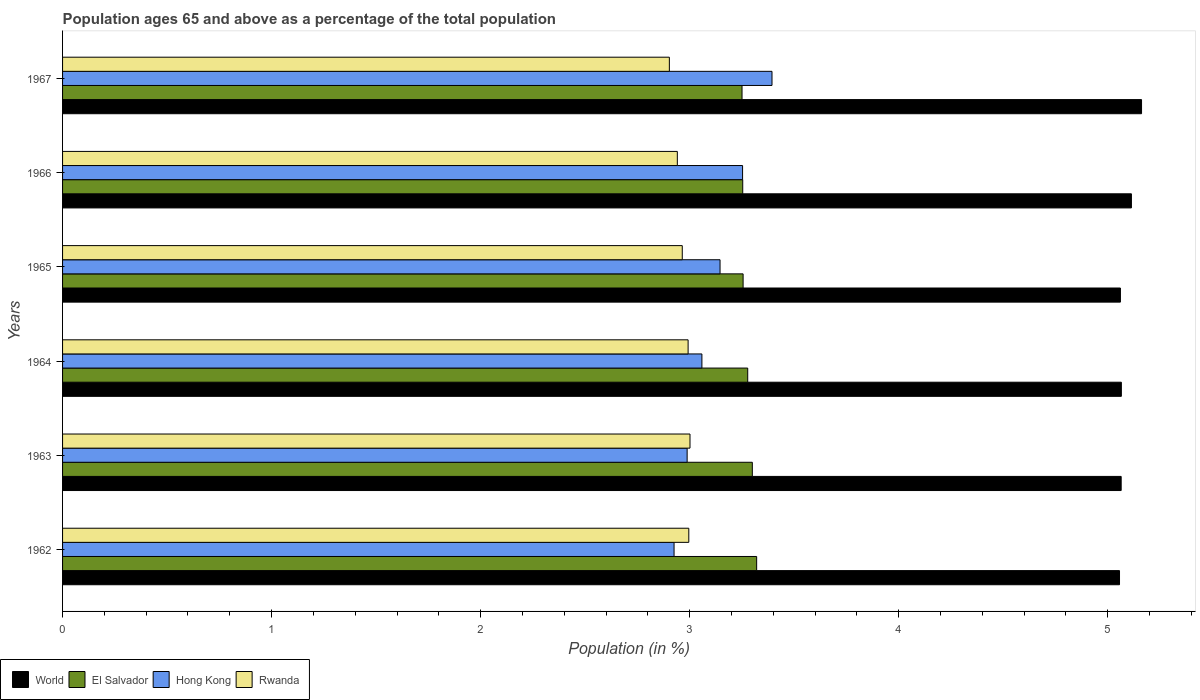How many different coloured bars are there?
Offer a very short reply. 4. Are the number of bars on each tick of the Y-axis equal?
Your answer should be very brief. Yes. How many bars are there on the 1st tick from the top?
Provide a short and direct response. 4. How many bars are there on the 4th tick from the bottom?
Ensure brevity in your answer.  4. In how many cases, is the number of bars for a given year not equal to the number of legend labels?
Ensure brevity in your answer.  0. What is the percentage of the population ages 65 and above in World in 1967?
Keep it short and to the point. 5.16. Across all years, what is the maximum percentage of the population ages 65 and above in Hong Kong?
Provide a short and direct response. 3.39. Across all years, what is the minimum percentage of the population ages 65 and above in Rwanda?
Your response must be concise. 2.9. In which year was the percentage of the population ages 65 and above in El Salvador maximum?
Your answer should be compact. 1962. In which year was the percentage of the population ages 65 and above in Rwanda minimum?
Offer a very short reply. 1967. What is the total percentage of the population ages 65 and above in Hong Kong in the graph?
Provide a short and direct response. 18.76. What is the difference between the percentage of the population ages 65 and above in El Salvador in 1963 and that in 1964?
Offer a very short reply. 0.02. What is the difference between the percentage of the population ages 65 and above in Rwanda in 1964 and the percentage of the population ages 65 and above in World in 1963?
Provide a short and direct response. -2.07. What is the average percentage of the population ages 65 and above in World per year?
Your response must be concise. 5.09. In the year 1963, what is the difference between the percentage of the population ages 65 and above in World and percentage of the population ages 65 and above in Hong Kong?
Keep it short and to the point. 2.08. What is the ratio of the percentage of the population ages 65 and above in World in 1966 to that in 1967?
Offer a terse response. 0.99. What is the difference between the highest and the second highest percentage of the population ages 65 and above in El Salvador?
Offer a very short reply. 0.02. What is the difference between the highest and the lowest percentage of the population ages 65 and above in Hong Kong?
Provide a succinct answer. 0.47. Is it the case that in every year, the sum of the percentage of the population ages 65 and above in Rwanda and percentage of the population ages 65 and above in World is greater than the sum of percentage of the population ages 65 and above in El Salvador and percentage of the population ages 65 and above in Hong Kong?
Offer a very short reply. Yes. What does the 2nd bar from the top in 1962 represents?
Your answer should be very brief. Hong Kong. Is it the case that in every year, the sum of the percentage of the population ages 65 and above in Rwanda and percentage of the population ages 65 and above in Hong Kong is greater than the percentage of the population ages 65 and above in World?
Your response must be concise. Yes. Are all the bars in the graph horizontal?
Your answer should be compact. Yes. How many years are there in the graph?
Your answer should be compact. 6. What is the difference between two consecutive major ticks on the X-axis?
Provide a succinct answer. 1. Does the graph contain grids?
Provide a succinct answer. No. How many legend labels are there?
Keep it short and to the point. 4. What is the title of the graph?
Give a very brief answer. Population ages 65 and above as a percentage of the total population. What is the Population (in %) of World in 1962?
Keep it short and to the point. 5.06. What is the Population (in %) of El Salvador in 1962?
Your answer should be very brief. 3.32. What is the Population (in %) in Hong Kong in 1962?
Provide a succinct answer. 2.93. What is the Population (in %) of Rwanda in 1962?
Your answer should be very brief. 3. What is the Population (in %) in World in 1963?
Offer a very short reply. 5.06. What is the Population (in %) in El Salvador in 1963?
Your answer should be compact. 3.3. What is the Population (in %) in Hong Kong in 1963?
Ensure brevity in your answer.  2.99. What is the Population (in %) of Rwanda in 1963?
Give a very brief answer. 3. What is the Population (in %) of World in 1964?
Give a very brief answer. 5.07. What is the Population (in %) of El Salvador in 1964?
Your answer should be compact. 3.28. What is the Population (in %) in Hong Kong in 1964?
Make the answer very short. 3.06. What is the Population (in %) in Rwanda in 1964?
Your response must be concise. 2.99. What is the Population (in %) in World in 1965?
Ensure brevity in your answer.  5.06. What is the Population (in %) in El Salvador in 1965?
Give a very brief answer. 3.26. What is the Population (in %) in Hong Kong in 1965?
Ensure brevity in your answer.  3.15. What is the Population (in %) in Rwanda in 1965?
Your answer should be very brief. 2.96. What is the Population (in %) of World in 1966?
Your answer should be compact. 5.11. What is the Population (in %) of El Salvador in 1966?
Make the answer very short. 3.25. What is the Population (in %) of Hong Kong in 1966?
Your response must be concise. 3.25. What is the Population (in %) of Rwanda in 1966?
Provide a short and direct response. 2.94. What is the Population (in %) in World in 1967?
Provide a succinct answer. 5.16. What is the Population (in %) in El Salvador in 1967?
Provide a succinct answer. 3.25. What is the Population (in %) in Hong Kong in 1967?
Your answer should be very brief. 3.39. What is the Population (in %) of Rwanda in 1967?
Provide a succinct answer. 2.9. Across all years, what is the maximum Population (in %) of World?
Your response must be concise. 5.16. Across all years, what is the maximum Population (in %) of El Salvador?
Keep it short and to the point. 3.32. Across all years, what is the maximum Population (in %) in Hong Kong?
Your answer should be compact. 3.39. Across all years, what is the maximum Population (in %) in Rwanda?
Provide a succinct answer. 3. Across all years, what is the minimum Population (in %) of World?
Ensure brevity in your answer.  5.06. Across all years, what is the minimum Population (in %) in El Salvador?
Your answer should be compact. 3.25. Across all years, what is the minimum Population (in %) of Hong Kong?
Make the answer very short. 2.93. Across all years, what is the minimum Population (in %) in Rwanda?
Your answer should be compact. 2.9. What is the total Population (in %) of World in the graph?
Provide a succinct answer. 30.52. What is the total Population (in %) in El Salvador in the graph?
Provide a succinct answer. 19.66. What is the total Population (in %) in Hong Kong in the graph?
Make the answer very short. 18.76. What is the total Population (in %) of Rwanda in the graph?
Your answer should be very brief. 17.8. What is the difference between the Population (in %) in World in 1962 and that in 1963?
Make the answer very short. -0.01. What is the difference between the Population (in %) of El Salvador in 1962 and that in 1963?
Provide a short and direct response. 0.02. What is the difference between the Population (in %) in Hong Kong in 1962 and that in 1963?
Give a very brief answer. -0.06. What is the difference between the Population (in %) in Rwanda in 1962 and that in 1963?
Give a very brief answer. -0.01. What is the difference between the Population (in %) in World in 1962 and that in 1964?
Your response must be concise. -0.01. What is the difference between the Population (in %) in El Salvador in 1962 and that in 1964?
Make the answer very short. 0.04. What is the difference between the Population (in %) of Hong Kong in 1962 and that in 1964?
Keep it short and to the point. -0.13. What is the difference between the Population (in %) in Rwanda in 1962 and that in 1964?
Keep it short and to the point. 0. What is the difference between the Population (in %) in World in 1962 and that in 1965?
Provide a short and direct response. -0. What is the difference between the Population (in %) of El Salvador in 1962 and that in 1965?
Give a very brief answer. 0.06. What is the difference between the Population (in %) of Hong Kong in 1962 and that in 1965?
Make the answer very short. -0.22. What is the difference between the Population (in %) of Rwanda in 1962 and that in 1965?
Keep it short and to the point. 0.03. What is the difference between the Population (in %) in World in 1962 and that in 1966?
Your response must be concise. -0.06. What is the difference between the Population (in %) in El Salvador in 1962 and that in 1966?
Your answer should be very brief. 0.07. What is the difference between the Population (in %) in Hong Kong in 1962 and that in 1966?
Offer a very short reply. -0.33. What is the difference between the Population (in %) of Rwanda in 1962 and that in 1966?
Offer a terse response. 0.05. What is the difference between the Population (in %) of World in 1962 and that in 1967?
Provide a short and direct response. -0.11. What is the difference between the Population (in %) in El Salvador in 1962 and that in 1967?
Your response must be concise. 0.07. What is the difference between the Population (in %) in Hong Kong in 1962 and that in 1967?
Ensure brevity in your answer.  -0.47. What is the difference between the Population (in %) in Rwanda in 1962 and that in 1967?
Offer a very short reply. 0.09. What is the difference between the Population (in %) of World in 1963 and that in 1964?
Your response must be concise. -0. What is the difference between the Population (in %) of El Salvador in 1963 and that in 1964?
Give a very brief answer. 0.02. What is the difference between the Population (in %) in Hong Kong in 1963 and that in 1964?
Offer a terse response. -0.07. What is the difference between the Population (in %) of Rwanda in 1963 and that in 1964?
Give a very brief answer. 0.01. What is the difference between the Population (in %) in World in 1963 and that in 1965?
Provide a short and direct response. 0. What is the difference between the Population (in %) of El Salvador in 1963 and that in 1965?
Ensure brevity in your answer.  0.04. What is the difference between the Population (in %) of Hong Kong in 1963 and that in 1965?
Your answer should be compact. -0.16. What is the difference between the Population (in %) of Rwanda in 1963 and that in 1965?
Your answer should be very brief. 0.04. What is the difference between the Population (in %) of World in 1963 and that in 1966?
Provide a succinct answer. -0.05. What is the difference between the Population (in %) in El Salvador in 1963 and that in 1966?
Provide a succinct answer. 0.05. What is the difference between the Population (in %) of Hong Kong in 1963 and that in 1966?
Your answer should be very brief. -0.27. What is the difference between the Population (in %) of Rwanda in 1963 and that in 1966?
Your answer should be very brief. 0.06. What is the difference between the Population (in %) of World in 1963 and that in 1967?
Your response must be concise. -0.1. What is the difference between the Population (in %) in El Salvador in 1963 and that in 1967?
Offer a very short reply. 0.05. What is the difference between the Population (in %) in Hong Kong in 1963 and that in 1967?
Make the answer very short. -0.41. What is the difference between the Population (in %) of Rwanda in 1963 and that in 1967?
Ensure brevity in your answer.  0.1. What is the difference between the Population (in %) in World in 1964 and that in 1965?
Your answer should be very brief. 0. What is the difference between the Population (in %) in El Salvador in 1964 and that in 1965?
Your answer should be compact. 0.02. What is the difference between the Population (in %) in Hong Kong in 1964 and that in 1965?
Your answer should be compact. -0.09. What is the difference between the Population (in %) in Rwanda in 1964 and that in 1965?
Offer a terse response. 0.03. What is the difference between the Population (in %) in World in 1964 and that in 1966?
Make the answer very short. -0.05. What is the difference between the Population (in %) in El Salvador in 1964 and that in 1966?
Offer a very short reply. 0.02. What is the difference between the Population (in %) in Hong Kong in 1964 and that in 1966?
Your response must be concise. -0.19. What is the difference between the Population (in %) of Rwanda in 1964 and that in 1966?
Your response must be concise. 0.05. What is the difference between the Population (in %) in World in 1964 and that in 1967?
Ensure brevity in your answer.  -0.1. What is the difference between the Population (in %) in El Salvador in 1964 and that in 1967?
Your answer should be compact. 0.03. What is the difference between the Population (in %) in Hong Kong in 1964 and that in 1967?
Offer a terse response. -0.34. What is the difference between the Population (in %) of Rwanda in 1964 and that in 1967?
Make the answer very short. 0.09. What is the difference between the Population (in %) in World in 1965 and that in 1966?
Your response must be concise. -0.05. What is the difference between the Population (in %) in El Salvador in 1965 and that in 1966?
Offer a very short reply. 0. What is the difference between the Population (in %) in Hong Kong in 1965 and that in 1966?
Your answer should be very brief. -0.11. What is the difference between the Population (in %) of Rwanda in 1965 and that in 1966?
Ensure brevity in your answer.  0.02. What is the difference between the Population (in %) of World in 1965 and that in 1967?
Your answer should be compact. -0.1. What is the difference between the Population (in %) of El Salvador in 1965 and that in 1967?
Provide a short and direct response. 0.01. What is the difference between the Population (in %) in Hong Kong in 1965 and that in 1967?
Provide a succinct answer. -0.25. What is the difference between the Population (in %) of Rwanda in 1965 and that in 1967?
Your answer should be very brief. 0.06. What is the difference between the Population (in %) in World in 1966 and that in 1967?
Offer a terse response. -0.05. What is the difference between the Population (in %) of El Salvador in 1966 and that in 1967?
Give a very brief answer. 0. What is the difference between the Population (in %) of Hong Kong in 1966 and that in 1967?
Your answer should be compact. -0.14. What is the difference between the Population (in %) in Rwanda in 1966 and that in 1967?
Make the answer very short. 0.04. What is the difference between the Population (in %) in World in 1962 and the Population (in %) in El Salvador in 1963?
Your response must be concise. 1.76. What is the difference between the Population (in %) of World in 1962 and the Population (in %) of Hong Kong in 1963?
Offer a very short reply. 2.07. What is the difference between the Population (in %) of World in 1962 and the Population (in %) of Rwanda in 1963?
Keep it short and to the point. 2.05. What is the difference between the Population (in %) in El Salvador in 1962 and the Population (in %) in Hong Kong in 1963?
Provide a short and direct response. 0.33. What is the difference between the Population (in %) in El Salvador in 1962 and the Population (in %) in Rwanda in 1963?
Your response must be concise. 0.32. What is the difference between the Population (in %) of Hong Kong in 1962 and the Population (in %) of Rwanda in 1963?
Provide a succinct answer. -0.08. What is the difference between the Population (in %) in World in 1962 and the Population (in %) in El Salvador in 1964?
Your response must be concise. 1.78. What is the difference between the Population (in %) of World in 1962 and the Population (in %) of Hong Kong in 1964?
Offer a very short reply. 2. What is the difference between the Population (in %) of World in 1962 and the Population (in %) of Rwanda in 1964?
Make the answer very short. 2.06. What is the difference between the Population (in %) of El Salvador in 1962 and the Population (in %) of Hong Kong in 1964?
Your answer should be compact. 0.26. What is the difference between the Population (in %) in El Salvador in 1962 and the Population (in %) in Rwanda in 1964?
Your answer should be very brief. 0.33. What is the difference between the Population (in %) in Hong Kong in 1962 and the Population (in %) in Rwanda in 1964?
Your answer should be compact. -0.07. What is the difference between the Population (in %) of World in 1962 and the Population (in %) of El Salvador in 1965?
Make the answer very short. 1.8. What is the difference between the Population (in %) in World in 1962 and the Population (in %) in Hong Kong in 1965?
Make the answer very short. 1.91. What is the difference between the Population (in %) of World in 1962 and the Population (in %) of Rwanda in 1965?
Ensure brevity in your answer.  2.09. What is the difference between the Population (in %) in El Salvador in 1962 and the Population (in %) in Hong Kong in 1965?
Give a very brief answer. 0.18. What is the difference between the Population (in %) in El Salvador in 1962 and the Population (in %) in Rwanda in 1965?
Offer a very short reply. 0.36. What is the difference between the Population (in %) of Hong Kong in 1962 and the Population (in %) of Rwanda in 1965?
Your answer should be very brief. -0.04. What is the difference between the Population (in %) of World in 1962 and the Population (in %) of El Salvador in 1966?
Provide a short and direct response. 1.8. What is the difference between the Population (in %) in World in 1962 and the Population (in %) in Hong Kong in 1966?
Your response must be concise. 1.8. What is the difference between the Population (in %) in World in 1962 and the Population (in %) in Rwanda in 1966?
Ensure brevity in your answer.  2.12. What is the difference between the Population (in %) of El Salvador in 1962 and the Population (in %) of Hong Kong in 1966?
Ensure brevity in your answer.  0.07. What is the difference between the Population (in %) of El Salvador in 1962 and the Population (in %) of Rwanda in 1966?
Make the answer very short. 0.38. What is the difference between the Population (in %) of Hong Kong in 1962 and the Population (in %) of Rwanda in 1966?
Offer a terse response. -0.02. What is the difference between the Population (in %) in World in 1962 and the Population (in %) in El Salvador in 1967?
Provide a succinct answer. 1.81. What is the difference between the Population (in %) of World in 1962 and the Population (in %) of Hong Kong in 1967?
Provide a short and direct response. 1.66. What is the difference between the Population (in %) in World in 1962 and the Population (in %) in Rwanda in 1967?
Make the answer very short. 2.15. What is the difference between the Population (in %) in El Salvador in 1962 and the Population (in %) in Hong Kong in 1967?
Make the answer very short. -0.07. What is the difference between the Population (in %) of El Salvador in 1962 and the Population (in %) of Rwanda in 1967?
Offer a terse response. 0.42. What is the difference between the Population (in %) of Hong Kong in 1962 and the Population (in %) of Rwanda in 1967?
Make the answer very short. 0.02. What is the difference between the Population (in %) in World in 1963 and the Population (in %) in El Salvador in 1964?
Provide a succinct answer. 1.79. What is the difference between the Population (in %) of World in 1963 and the Population (in %) of Hong Kong in 1964?
Offer a very short reply. 2.01. What is the difference between the Population (in %) in World in 1963 and the Population (in %) in Rwanda in 1964?
Give a very brief answer. 2.07. What is the difference between the Population (in %) of El Salvador in 1963 and the Population (in %) of Hong Kong in 1964?
Provide a short and direct response. 0.24. What is the difference between the Population (in %) in El Salvador in 1963 and the Population (in %) in Rwanda in 1964?
Your answer should be very brief. 0.31. What is the difference between the Population (in %) of Hong Kong in 1963 and the Population (in %) of Rwanda in 1964?
Provide a short and direct response. -0. What is the difference between the Population (in %) of World in 1963 and the Population (in %) of El Salvador in 1965?
Your answer should be compact. 1.81. What is the difference between the Population (in %) of World in 1963 and the Population (in %) of Hong Kong in 1965?
Provide a short and direct response. 1.92. What is the difference between the Population (in %) in World in 1963 and the Population (in %) in Rwanda in 1965?
Give a very brief answer. 2.1. What is the difference between the Population (in %) in El Salvador in 1963 and the Population (in %) in Hong Kong in 1965?
Ensure brevity in your answer.  0.15. What is the difference between the Population (in %) in El Salvador in 1963 and the Population (in %) in Rwanda in 1965?
Offer a very short reply. 0.34. What is the difference between the Population (in %) of Hong Kong in 1963 and the Population (in %) of Rwanda in 1965?
Keep it short and to the point. 0.02. What is the difference between the Population (in %) of World in 1963 and the Population (in %) of El Salvador in 1966?
Make the answer very short. 1.81. What is the difference between the Population (in %) of World in 1963 and the Population (in %) of Hong Kong in 1966?
Ensure brevity in your answer.  1.81. What is the difference between the Population (in %) of World in 1963 and the Population (in %) of Rwanda in 1966?
Your answer should be compact. 2.12. What is the difference between the Population (in %) in El Salvador in 1963 and the Population (in %) in Hong Kong in 1966?
Give a very brief answer. 0.05. What is the difference between the Population (in %) of El Salvador in 1963 and the Population (in %) of Rwanda in 1966?
Your response must be concise. 0.36. What is the difference between the Population (in %) of Hong Kong in 1963 and the Population (in %) of Rwanda in 1966?
Provide a succinct answer. 0.05. What is the difference between the Population (in %) of World in 1963 and the Population (in %) of El Salvador in 1967?
Ensure brevity in your answer.  1.81. What is the difference between the Population (in %) of World in 1963 and the Population (in %) of Hong Kong in 1967?
Keep it short and to the point. 1.67. What is the difference between the Population (in %) in World in 1963 and the Population (in %) in Rwanda in 1967?
Ensure brevity in your answer.  2.16. What is the difference between the Population (in %) of El Salvador in 1963 and the Population (in %) of Hong Kong in 1967?
Offer a terse response. -0.09. What is the difference between the Population (in %) of El Salvador in 1963 and the Population (in %) of Rwanda in 1967?
Ensure brevity in your answer.  0.4. What is the difference between the Population (in %) of Hong Kong in 1963 and the Population (in %) of Rwanda in 1967?
Your answer should be very brief. 0.09. What is the difference between the Population (in %) of World in 1964 and the Population (in %) of El Salvador in 1965?
Provide a short and direct response. 1.81. What is the difference between the Population (in %) of World in 1964 and the Population (in %) of Hong Kong in 1965?
Give a very brief answer. 1.92. What is the difference between the Population (in %) of World in 1964 and the Population (in %) of Rwanda in 1965?
Provide a short and direct response. 2.1. What is the difference between the Population (in %) of El Salvador in 1964 and the Population (in %) of Hong Kong in 1965?
Your answer should be very brief. 0.13. What is the difference between the Population (in %) of El Salvador in 1964 and the Population (in %) of Rwanda in 1965?
Provide a short and direct response. 0.31. What is the difference between the Population (in %) of Hong Kong in 1964 and the Population (in %) of Rwanda in 1965?
Make the answer very short. 0.09. What is the difference between the Population (in %) of World in 1964 and the Population (in %) of El Salvador in 1966?
Give a very brief answer. 1.81. What is the difference between the Population (in %) of World in 1964 and the Population (in %) of Hong Kong in 1966?
Make the answer very short. 1.81. What is the difference between the Population (in %) of World in 1964 and the Population (in %) of Rwanda in 1966?
Give a very brief answer. 2.12. What is the difference between the Population (in %) in El Salvador in 1964 and the Population (in %) in Hong Kong in 1966?
Your answer should be compact. 0.02. What is the difference between the Population (in %) in El Salvador in 1964 and the Population (in %) in Rwanda in 1966?
Your response must be concise. 0.34. What is the difference between the Population (in %) of Hong Kong in 1964 and the Population (in %) of Rwanda in 1966?
Make the answer very short. 0.12. What is the difference between the Population (in %) of World in 1964 and the Population (in %) of El Salvador in 1967?
Provide a short and direct response. 1.81. What is the difference between the Population (in %) of World in 1964 and the Population (in %) of Hong Kong in 1967?
Your answer should be very brief. 1.67. What is the difference between the Population (in %) of World in 1964 and the Population (in %) of Rwanda in 1967?
Ensure brevity in your answer.  2.16. What is the difference between the Population (in %) in El Salvador in 1964 and the Population (in %) in Hong Kong in 1967?
Your answer should be compact. -0.12. What is the difference between the Population (in %) of El Salvador in 1964 and the Population (in %) of Rwanda in 1967?
Offer a terse response. 0.37. What is the difference between the Population (in %) in Hong Kong in 1964 and the Population (in %) in Rwanda in 1967?
Your response must be concise. 0.16. What is the difference between the Population (in %) in World in 1965 and the Population (in %) in El Salvador in 1966?
Offer a terse response. 1.81. What is the difference between the Population (in %) of World in 1965 and the Population (in %) of Hong Kong in 1966?
Give a very brief answer. 1.81. What is the difference between the Population (in %) of World in 1965 and the Population (in %) of Rwanda in 1966?
Give a very brief answer. 2.12. What is the difference between the Population (in %) of El Salvador in 1965 and the Population (in %) of Hong Kong in 1966?
Provide a short and direct response. 0. What is the difference between the Population (in %) of El Salvador in 1965 and the Population (in %) of Rwanda in 1966?
Offer a very short reply. 0.31. What is the difference between the Population (in %) of Hong Kong in 1965 and the Population (in %) of Rwanda in 1966?
Your answer should be very brief. 0.2. What is the difference between the Population (in %) of World in 1965 and the Population (in %) of El Salvador in 1967?
Offer a terse response. 1.81. What is the difference between the Population (in %) of World in 1965 and the Population (in %) of Hong Kong in 1967?
Give a very brief answer. 1.67. What is the difference between the Population (in %) of World in 1965 and the Population (in %) of Rwanda in 1967?
Ensure brevity in your answer.  2.16. What is the difference between the Population (in %) in El Salvador in 1965 and the Population (in %) in Hong Kong in 1967?
Provide a short and direct response. -0.14. What is the difference between the Population (in %) of El Salvador in 1965 and the Population (in %) of Rwanda in 1967?
Your answer should be very brief. 0.35. What is the difference between the Population (in %) in Hong Kong in 1965 and the Population (in %) in Rwanda in 1967?
Your answer should be very brief. 0.24. What is the difference between the Population (in %) in World in 1966 and the Population (in %) in El Salvador in 1967?
Your response must be concise. 1.86. What is the difference between the Population (in %) in World in 1966 and the Population (in %) in Hong Kong in 1967?
Offer a very short reply. 1.72. What is the difference between the Population (in %) of World in 1966 and the Population (in %) of Rwanda in 1967?
Your answer should be compact. 2.21. What is the difference between the Population (in %) in El Salvador in 1966 and the Population (in %) in Hong Kong in 1967?
Offer a very short reply. -0.14. What is the difference between the Population (in %) in El Salvador in 1966 and the Population (in %) in Rwanda in 1967?
Offer a very short reply. 0.35. What is the difference between the Population (in %) in Hong Kong in 1966 and the Population (in %) in Rwanda in 1967?
Offer a very short reply. 0.35. What is the average Population (in %) of World per year?
Keep it short and to the point. 5.09. What is the average Population (in %) of El Salvador per year?
Your answer should be very brief. 3.28. What is the average Population (in %) in Hong Kong per year?
Provide a succinct answer. 3.13. What is the average Population (in %) of Rwanda per year?
Your response must be concise. 2.97. In the year 1962, what is the difference between the Population (in %) of World and Population (in %) of El Salvador?
Provide a succinct answer. 1.74. In the year 1962, what is the difference between the Population (in %) in World and Population (in %) in Hong Kong?
Keep it short and to the point. 2.13. In the year 1962, what is the difference between the Population (in %) in World and Population (in %) in Rwanda?
Provide a succinct answer. 2.06. In the year 1962, what is the difference between the Population (in %) in El Salvador and Population (in %) in Hong Kong?
Offer a terse response. 0.4. In the year 1962, what is the difference between the Population (in %) of El Salvador and Population (in %) of Rwanda?
Make the answer very short. 0.32. In the year 1962, what is the difference between the Population (in %) of Hong Kong and Population (in %) of Rwanda?
Make the answer very short. -0.07. In the year 1963, what is the difference between the Population (in %) in World and Population (in %) in El Salvador?
Give a very brief answer. 1.76. In the year 1963, what is the difference between the Population (in %) of World and Population (in %) of Hong Kong?
Ensure brevity in your answer.  2.08. In the year 1963, what is the difference between the Population (in %) of World and Population (in %) of Rwanda?
Keep it short and to the point. 2.06. In the year 1963, what is the difference between the Population (in %) of El Salvador and Population (in %) of Hong Kong?
Provide a succinct answer. 0.31. In the year 1963, what is the difference between the Population (in %) of El Salvador and Population (in %) of Rwanda?
Offer a terse response. 0.3. In the year 1963, what is the difference between the Population (in %) in Hong Kong and Population (in %) in Rwanda?
Give a very brief answer. -0.01. In the year 1964, what is the difference between the Population (in %) in World and Population (in %) in El Salvador?
Provide a short and direct response. 1.79. In the year 1964, what is the difference between the Population (in %) of World and Population (in %) of Hong Kong?
Your answer should be very brief. 2.01. In the year 1964, what is the difference between the Population (in %) of World and Population (in %) of Rwanda?
Your response must be concise. 2.07. In the year 1964, what is the difference between the Population (in %) of El Salvador and Population (in %) of Hong Kong?
Your response must be concise. 0.22. In the year 1964, what is the difference between the Population (in %) in El Salvador and Population (in %) in Rwanda?
Give a very brief answer. 0.29. In the year 1964, what is the difference between the Population (in %) in Hong Kong and Population (in %) in Rwanda?
Provide a short and direct response. 0.07. In the year 1965, what is the difference between the Population (in %) of World and Population (in %) of El Salvador?
Offer a terse response. 1.8. In the year 1965, what is the difference between the Population (in %) of World and Population (in %) of Hong Kong?
Your response must be concise. 1.92. In the year 1965, what is the difference between the Population (in %) in World and Population (in %) in Rwanda?
Make the answer very short. 2.1. In the year 1965, what is the difference between the Population (in %) in El Salvador and Population (in %) in Hong Kong?
Your response must be concise. 0.11. In the year 1965, what is the difference between the Population (in %) of El Salvador and Population (in %) of Rwanda?
Make the answer very short. 0.29. In the year 1965, what is the difference between the Population (in %) in Hong Kong and Population (in %) in Rwanda?
Offer a terse response. 0.18. In the year 1966, what is the difference between the Population (in %) in World and Population (in %) in El Salvador?
Ensure brevity in your answer.  1.86. In the year 1966, what is the difference between the Population (in %) in World and Population (in %) in Hong Kong?
Provide a short and direct response. 1.86. In the year 1966, what is the difference between the Population (in %) in World and Population (in %) in Rwanda?
Ensure brevity in your answer.  2.17. In the year 1966, what is the difference between the Population (in %) in El Salvador and Population (in %) in Hong Kong?
Make the answer very short. 0. In the year 1966, what is the difference between the Population (in %) in El Salvador and Population (in %) in Rwanda?
Provide a succinct answer. 0.31. In the year 1966, what is the difference between the Population (in %) in Hong Kong and Population (in %) in Rwanda?
Your answer should be compact. 0.31. In the year 1967, what is the difference between the Population (in %) of World and Population (in %) of El Salvador?
Provide a short and direct response. 1.91. In the year 1967, what is the difference between the Population (in %) in World and Population (in %) in Hong Kong?
Your answer should be very brief. 1.77. In the year 1967, what is the difference between the Population (in %) in World and Population (in %) in Rwanda?
Keep it short and to the point. 2.26. In the year 1967, what is the difference between the Population (in %) of El Salvador and Population (in %) of Hong Kong?
Your response must be concise. -0.14. In the year 1967, what is the difference between the Population (in %) in El Salvador and Population (in %) in Rwanda?
Your response must be concise. 0.35. In the year 1967, what is the difference between the Population (in %) in Hong Kong and Population (in %) in Rwanda?
Offer a terse response. 0.49. What is the ratio of the Population (in %) in World in 1962 to that in 1963?
Provide a succinct answer. 1. What is the ratio of the Population (in %) in Hong Kong in 1962 to that in 1963?
Offer a terse response. 0.98. What is the ratio of the Population (in %) of El Salvador in 1962 to that in 1964?
Provide a succinct answer. 1.01. What is the ratio of the Population (in %) in Hong Kong in 1962 to that in 1964?
Offer a terse response. 0.96. What is the ratio of the Population (in %) of Rwanda in 1962 to that in 1964?
Offer a very short reply. 1. What is the ratio of the Population (in %) in El Salvador in 1962 to that in 1965?
Your answer should be compact. 1.02. What is the ratio of the Population (in %) in Hong Kong in 1962 to that in 1965?
Provide a succinct answer. 0.93. What is the ratio of the Population (in %) in Rwanda in 1962 to that in 1965?
Keep it short and to the point. 1.01. What is the ratio of the Population (in %) in World in 1962 to that in 1966?
Provide a short and direct response. 0.99. What is the ratio of the Population (in %) of El Salvador in 1962 to that in 1966?
Offer a terse response. 1.02. What is the ratio of the Population (in %) of Hong Kong in 1962 to that in 1966?
Your answer should be compact. 0.9. What is the ratio of the Population (in %) in Rwanda in 1962 to that in 1966?
Keep it short and to the point. 1.02. What is the ratio of the Population (in %) in World in 1962 to that in 1967?
Offer a very short reply. 0.98. What is the ratio of the Population (in %) in El Salvador in 1962 to that in 1967?
Your answer should be compact. 1.02. What is the ratio of the Population (in %) in Hong Kong in 1962 to that in 1967?
Provide a short and direct response. 0.86. What is the ratio of the Population (in %) of Rwanda in 1962 to that in 1967?
Offer a very short reply. 1.03. What is the ratio of the Population (in %) of Hong Kong in 1963 to that in 1964?
Provide a succinct answer. 0.98. What is the ratio of the Population (in %) in El Salvador in 1963 to that in 1965?
Provide a short and direct response. 1.01. What is the ratio of the Population (in %) in Rwanda in 1963 to that in 1965?
Provide a short and direct response. 1.01. What is the ratio of the Population (in %) in El Salvador in 1963 to that in 1966?
Offer a very short reply. 1.01. What is the ratio of the Population (in %) in Hong Kong in 1963 to that in 1966?
Provide a succinct answer. 0.92. What is the ratio of the Population (in %) in Rwanda in 1963 to that in 1966?
Your answer should be compact. 1.02. What is the ratio of the Population (in %) in World in 1963 to that in 1967?
Ensure brevity in your answer.  0.98. What is the ratio of the Population (in %) of El Salvador in 1963 to that in 1967?
Your answer should be compact. 1.02. What is the ratio of the Population (in %) in Hong Kong in 1963 to that in 1967?
Your answer should be very brief. 0.88. What is the ratio of the Population (in %) of Rwanda in 1963 to that in 1967?
Ensure brevity in your answer.  1.03. What is the ratio of the Population (in %) in World in 1964 to that in 1965?
Make the answer very short. 1. What is the ratio of the Population (in %) of El Salvador in 1964 to that in 1965?
Your response must be concise. 1.01. What is the ratio of the Population (in %) in Hong Kong in 1964 to that in 1965?
Your response must be concise. 0.97. What is the ratio of the Population (in %) of Rwanda in 1964 to that in 1965?
Keep it short and to the point. 1.01. What is the ratio of the Population (in %) of World in 1964 to that in 1966?
Provide a short and direct response. 0.99. What is the ratio of the Population (in %) in El Salvador in 1964 to that in 1966?
Your answer should be very brief. 1.01. What is the ratio of the Population (in %) in Hong Kong in 1964 to that in 1966?
Your response must be concise. 0.94. What is the ratio of the Population (in %) of Rwanda in 1964 to that in 1966?
Give a very brief answer. 1.02. What is the ratio of the Population (in %) in World in 1964 to that in 1967?
Your answer should be very brief. 0.98. What is the ratio of the Population (in %) of El Salvador in 1964 to that in 1967?
Your answer should be very brief. 1.01. What is the ratio of the Population (in %) in Hong Kong in 1964 to that in 1967?
Your answer should be very brief. 0.9. What is the ratio of the Population (in %) in Rwanda in 1964 to that in 1967?
Offer a very short reply. 1.03. What is the ratio of the Population (in %) of World in 1965 to that in 1966?
Provide a succinct answer. 0.99. What is the ratio of the Population (in %) in El Salvador in 1965 to that in 1966?
Your answer should be compact. 1. What is the ratio of the Population (in %) of Hong Kong in 1965 to that in 1966?
Keep it short and to the point. 0.97. What is the ratio of the Population (in %) in World in 1965 to that in 1967?
Offer a very short reply. 0.98. What is the ratio of the Population (in %) in El Salvador in 1965 to that in 1967?
Your answer should be very brief. 1. What is the ratio of the Population (in %) of Hong Kong in 1965 to that in 1967?
Your answer should be very brief. 0.93. What is the ratio of the Population (in %) in Rwanda in 1965 to that in 1967?
Keep it short and to the point. 1.02. What is the ratio of the Population (in %) in World in 1966 to that in 1967?
Keep it short and to the point. 0.99. What is the ratio of the Population (in %) in Hong Kong in 1966 to that in 1967?
Make the answer very short. 0.96. What is the ratio of the Population (in %) in Rwanda in 1966 to that in 1967?
Provide a succinct answer. 1.01. What is the difference between the highest and the second highest Population (in %) of World?
Your response must be concise. 0.05. What is the difference between the highest and the second highest Population (in %) in El Salvador?
Your answer should be very brief. 0.02. What is the difference between the highest and the second highest Population (in %) in Hong Kong?
Ensure brevity in your answer.  0.14. What is the difference between the highest and the second highest Population (in %) in Rwanda?
Ensure brevity in your answer.  0.01. What is the difference between the highest and the lowest Population (in %) in World?
Ensure brevity in your answer.  0.11. What is the difference between the highest and the lowest Population (in %) in El Salvador?
Your response must be concise. 0.07. What is the difference between the highest and the lowest Population (in %) of Hong Kong?
Make the answer very short. 0.47. What is the difference between the highest and the lowest Population (in %) of Rwanda?
Ensure brevity in your answer.  0.1. 